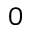<formula> <loc_0><loc_0><loc_500><loc_500>0</formula> 